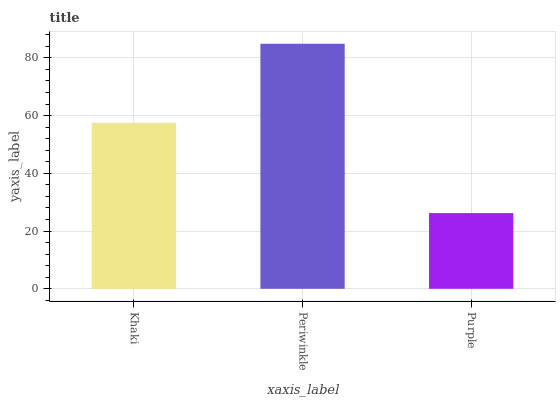Is Periwinkle the minimum?
Answer yes or no. No. Is Purple the maximum?
Answer yes or no. No. Is Periwinkle greater than Purple?
Answer yes or no. Yes. Is Purple less than Periwinkle?
Answer yes or no. Yes. Is Purple greater than Periwinkle?
Answer yes or no. No. Is Periwinkle less than Purple?
Answer yes or no. No. Is Khaki the high median?
Answer yes or no. Yes. Is Khaki the low median?
Answer yes or no. Yes. Is Purple the high median?
Answer yes or no. No. Is Purple the low median?
Answer yes or no. No. 